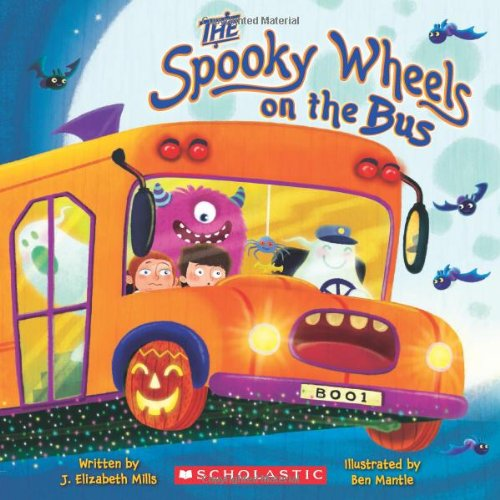What is the title of this book? The title of the book featured in the image is 'The Spooky Wheels on the Bus'. This catchy title is tailored to intrigue young audiences with a Halloween-themed spin on a classic children's song. 